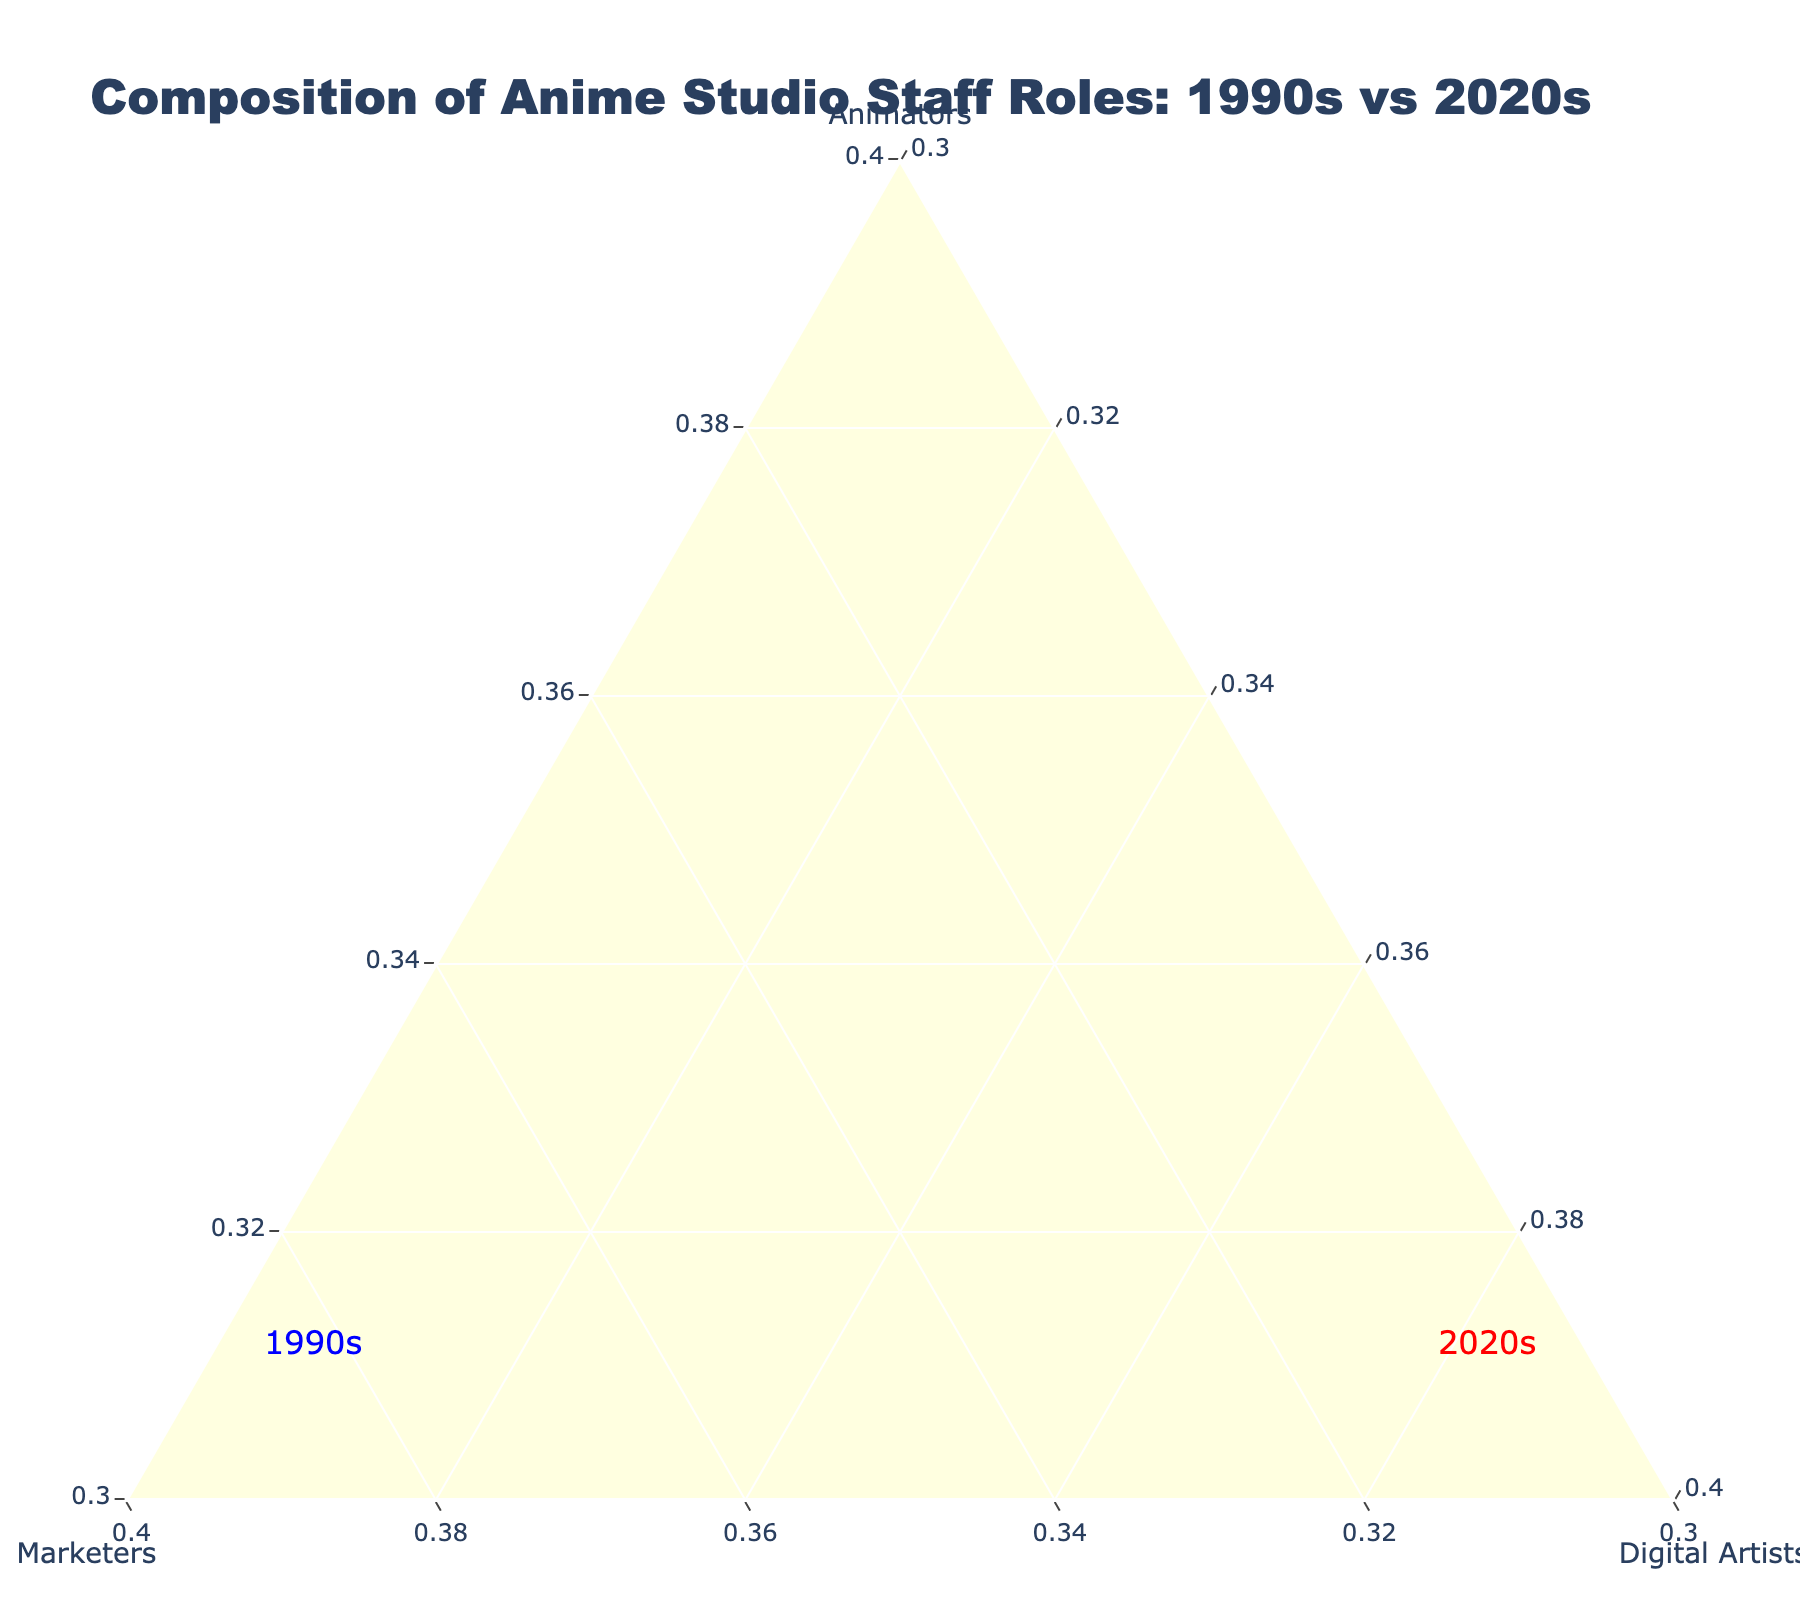What's the title of the plot? The title of the plot is displayed at the top center of the figure.
Answer: Composition of Anime Studio Staff Roles: 1990s vs 2020s How many studios are analyzed for the 1990s? Count the number of blue circles, as they represent studios in the 1990s.
Answer: 5 Which studio has the highest percentage of animators in the 2020s? Look for the red star that is positioned the highest along the 'Animators' axis.
Answer: Kyoto Animation What's the percentage of digital artists in Wit Studio in the 2020s? Identify Wit Studio on the plot and read its percentage on the 'Digital Artists' axis.
Answer: 15% How do the marketers' percentages differ between Studio Ghibli in 1995 and A-1 Pictures in 2022? Find Studio Ghibli 1995 and A-1 Pictures on the plot and subtract their respective marketers' percentages.
Answer: 25% - 10% = 15% What's the average percentage of digital artists in the 2020s? Sum the digital artists' percentages for all studios in the 2020s and divide by the number of these studios: ((15 + 15 + 15 + 15 + 20) / 5).
Answer: 16% Which era, the 1990s or the 2020s, generally has a higher proportion of marketers? Compare the general location along the 'Marketers' axis for red stars versus blue circles.
Answer: 2020s What's the combined percentage of non-animators in MAPPA in 2023? Sum the percentages of marketers and digital artists for MAPPA.
Answer: 30% + 15% = 45% What's the common visual marker for studios in the 1990s? Observe the shape and color used for studios in the 1990s on the plot.
Answer: Blue circles Which studio in the 2020s has the highest proportion of digital artists? Identify the red star closest to the 'Digital Artists' axis apex.
Answer: ufotable 